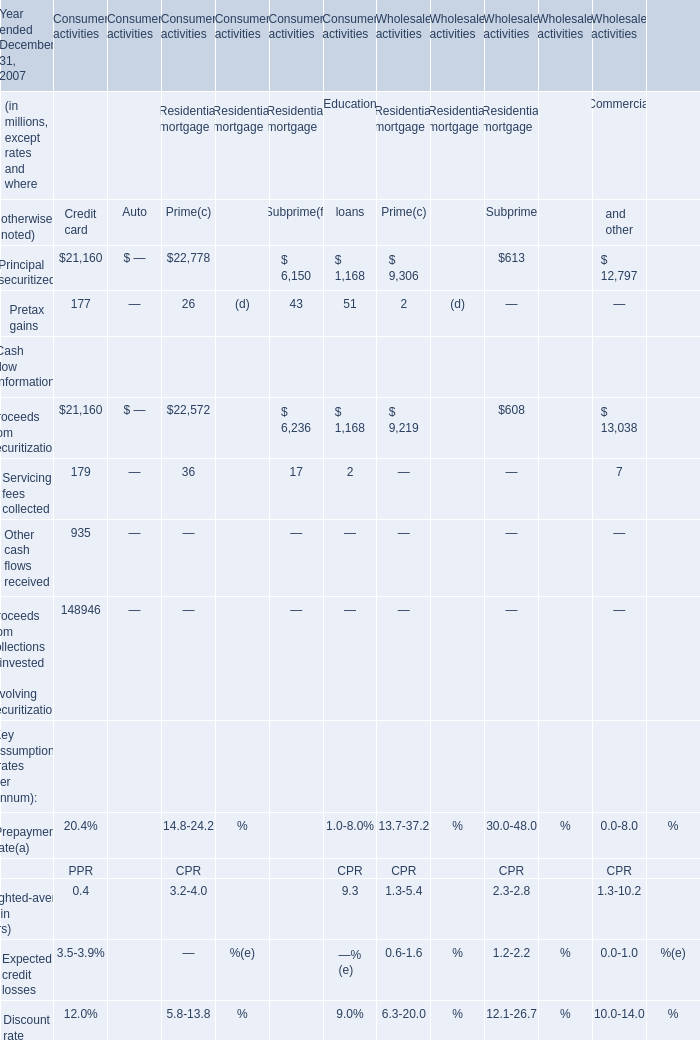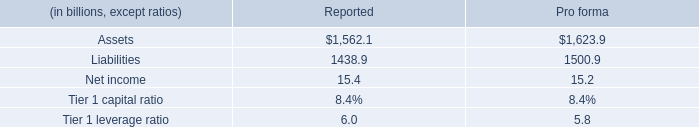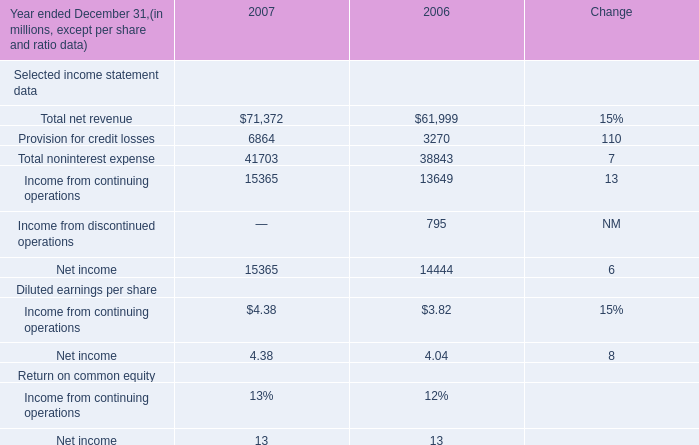What's the average of Principal securitized of Consumer activities Education loans is, and Provision for credit losses of 2007 ? 
Computations: ((1168.0 + 6864.0) / 2)
Answer: 4016.0. 